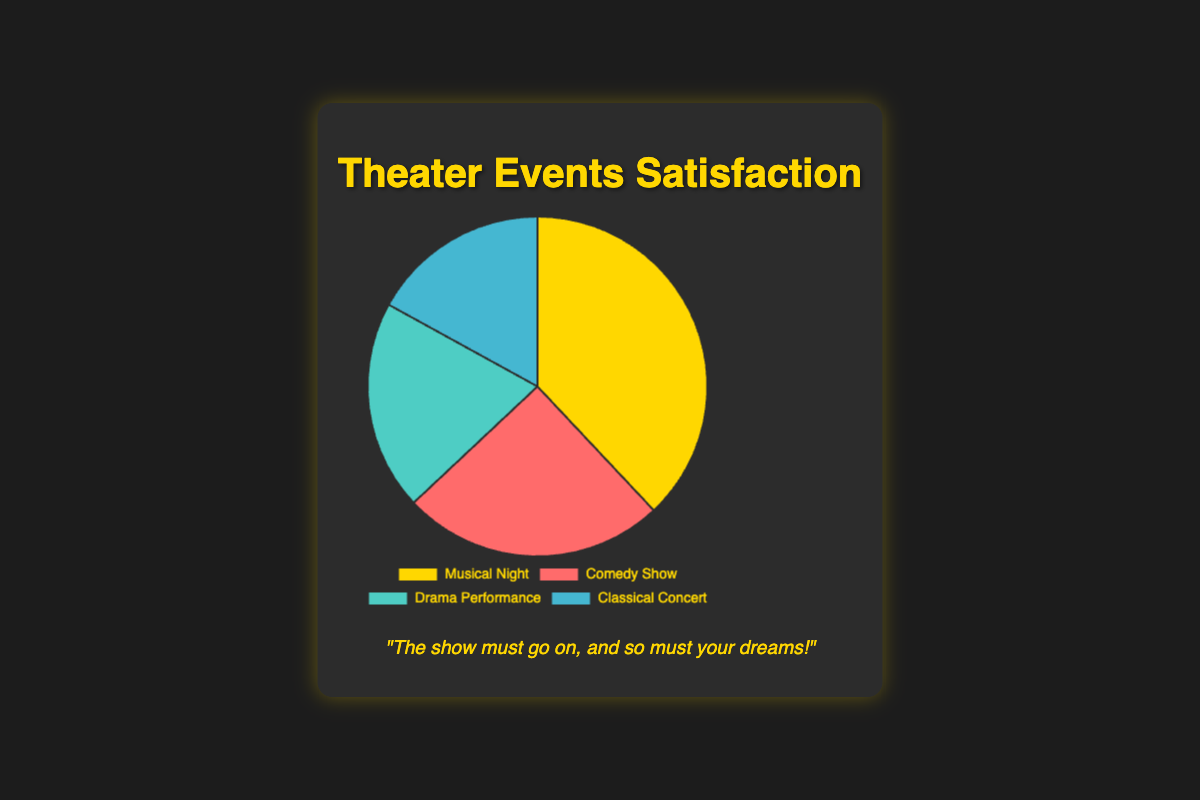Which event has the highest customer satisfaction level? By looking at the pie chart, identify which segment has the largest proportion. The segment labeled "Musical Night" takes up the most space on the pie chart.
Answer: Musical Night Which event has the lowest customer satisfaction level? By looking at the pie chart, identify which segment has the smallest proportion. The segment labeled "Classical Concert" takes up the least space on the pie chart.
Answer: Classical Concert How much greater is the satisfaction level for Musical Night compared to Classical Concert? Identify the proportions for both events from the pie chart. Musical Night has 38% and Classical Concert has 17%. Subtract 17% from 38% to find the difference.
Answer: 21% What is the combined satisfaction level for Comedy Show and Drama Performance? Identify the percentages for both events from the pie chart: 25% for Comedy Show and 20% for Drama Performance. Add these values together.
Answer: 45% Is the satisfaction level for Drama Performance more than, less than, or equal to the satisfaction level for Classical Concert? By comparing the segments of the pie chart, Drama Performance has 20% and Classical Concert has 17%. Since 20% is greater than 17%, Drama Performance has a higher satisfaction level.
Answer: More than What percentage of the pie chart is represented by Musical Night? By looking at the pie chart, note that the segment for Musical Night is 38%.
Answer: 38% Which events together make up over 50% of the customer satisfaction levels? By combining the percentages of the events in the pie chart, add up the highest values until you exceed 50%. Musical Night (38%) and Comedy Show (25%) together are 63%.
Answer: Musical Night and Comedy Show What is the average satisfaction level among all four events? Add up the percentages for all four events: 38% for Musical Night, 25% for Comedy Show, 20% for Drama Performance, and 17% for Classical Concert. Divide the total by four. (38+25+20+17) / 4 = 100 / 4 = 25
Answer: 25% Which event has a satisfaction level that is closest to the average satisfaction level? From the previously calculated average of 25%, compare it to each event's satisfaction level from the pie chart. Comedy Show has 25%, which is exactly the average.
Answer: Comedy Show 